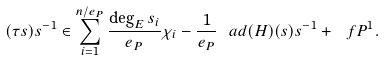Convert formula to latex. <formula><loc_0><loc_0><loc_500><loc_500>( \tau s ) s ^ { - 1 } \in \sum _ { i = 1 } ^ { n / e _ { P } } \frac { \deg _ { E } { s _ { i } } } { e _ { P } } \chi _ { i } - \frac { 1 } { e _ { P } } \ a d ( H ) ( s ) s ^ { - 1 } + \ f P ^ { 1 } .</formula> 